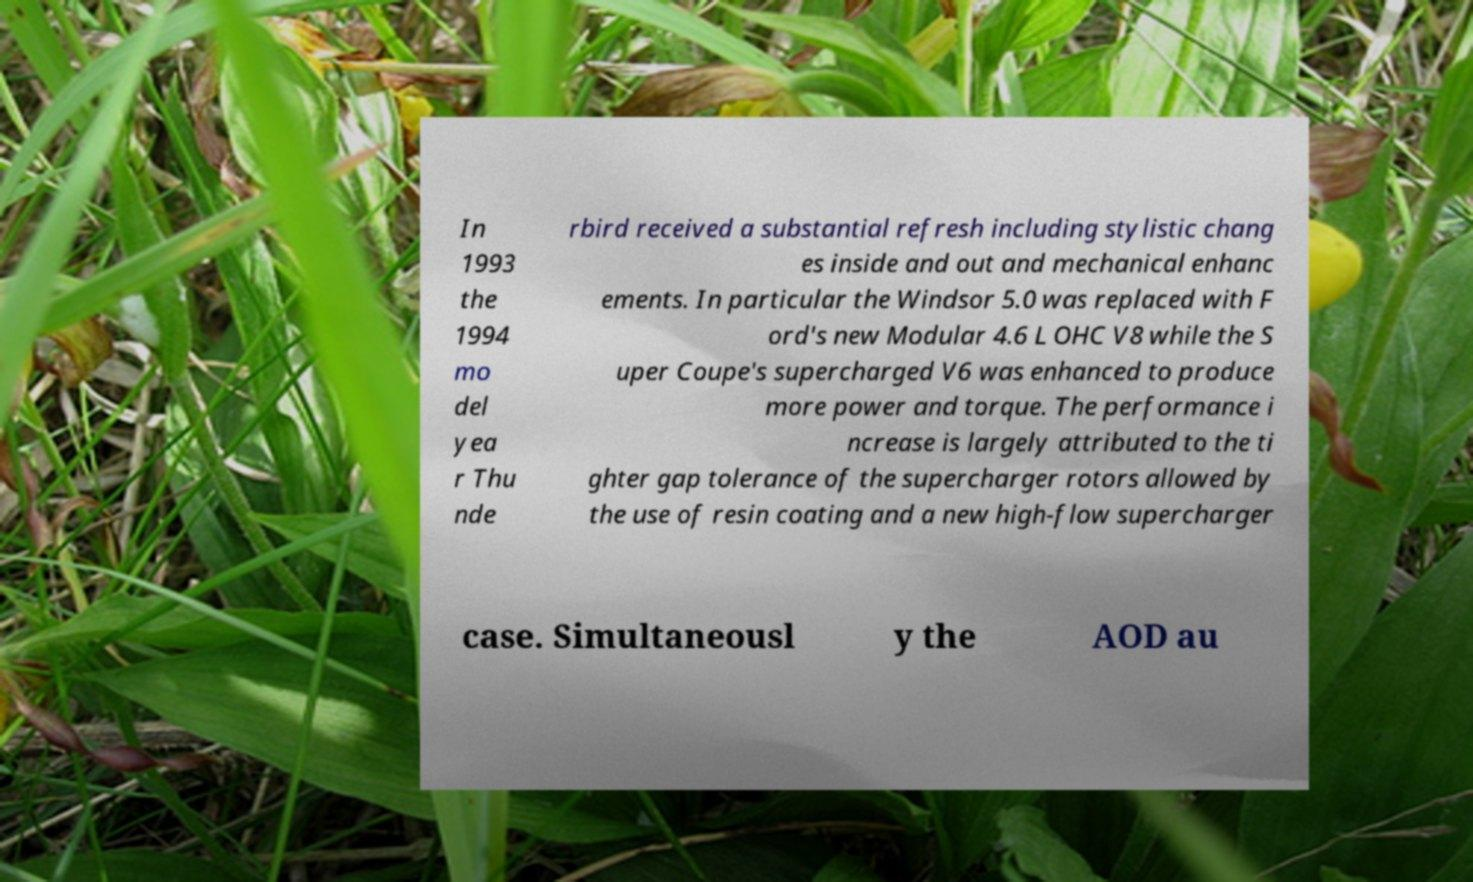Can you accurately transcribe the text from the provided image for me? In 1993 the 1994 mo del yea r Thu nde rbird received a substantial refresh including stylistic chang es inside and out and mechanical enhanc ements. In particular the Windsor 5.0 was replaced with F ord's new Modular 4.6 L OHC V8 while the S uper Coupe's supercharged V6 was enhanced to produce more power and torque. The performance i ncrease is largely attributed to the ti ghter gap tolerance of the supercharger rotors allowed by the use of resin coating and a new high-flow supercharger case. Simultaneousl y the AOD au 